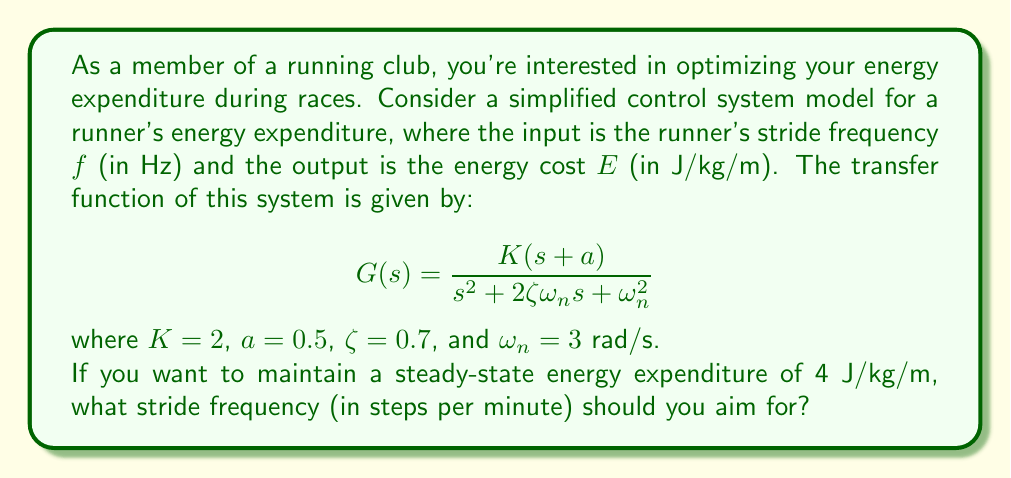Show me your answer to this math problem. To solve this problem, we need to follow these steps:

1) First, we need to determine the steady-state gain of the system. For a second-order system with a zero, the steady-state gain is given by:

   $$K_{ss} = \frac{K(a)}{{\omega_n}^2}$$

2) Substituting the given values:

   $$K_{ss} = \frac{2(0.5)}{3^2} = \frac{1}{9} \approx 0.1111$$

3) The steady-state gain represents the ratio of output to input at steady state. In this case:

   $$K_{ss} = \frac{E_{ss}}{f_{ss}}$$

   where $E_{ss}$ is the desired steady-state energy expenditure and $f_{ss}$ is the required steady-state stride frequency.

4) We know $E_{ss} = 4$ J/kg/m, so we can solve for $f_{ss}$:

   $$f_{ss} = \frac{E_{ss}}{K_{ss}} = \frac{4}{0.1111} = 36 \text{ Hz}$$

5) However, stride frequency is typically expressed in steps per minute rather than Hz. To convert:

   $$f_{steps/min} = f_{Hz} * 60 \text{ s/min} * 2 \text{ steps/cycle}$$

6) Substituting our value:

   $$f_{steps/min} = 36 * 60 * 2 = 4320 \text{ steps/min}$$
Answer: The required stride frequency is 4320 steps per minute. 